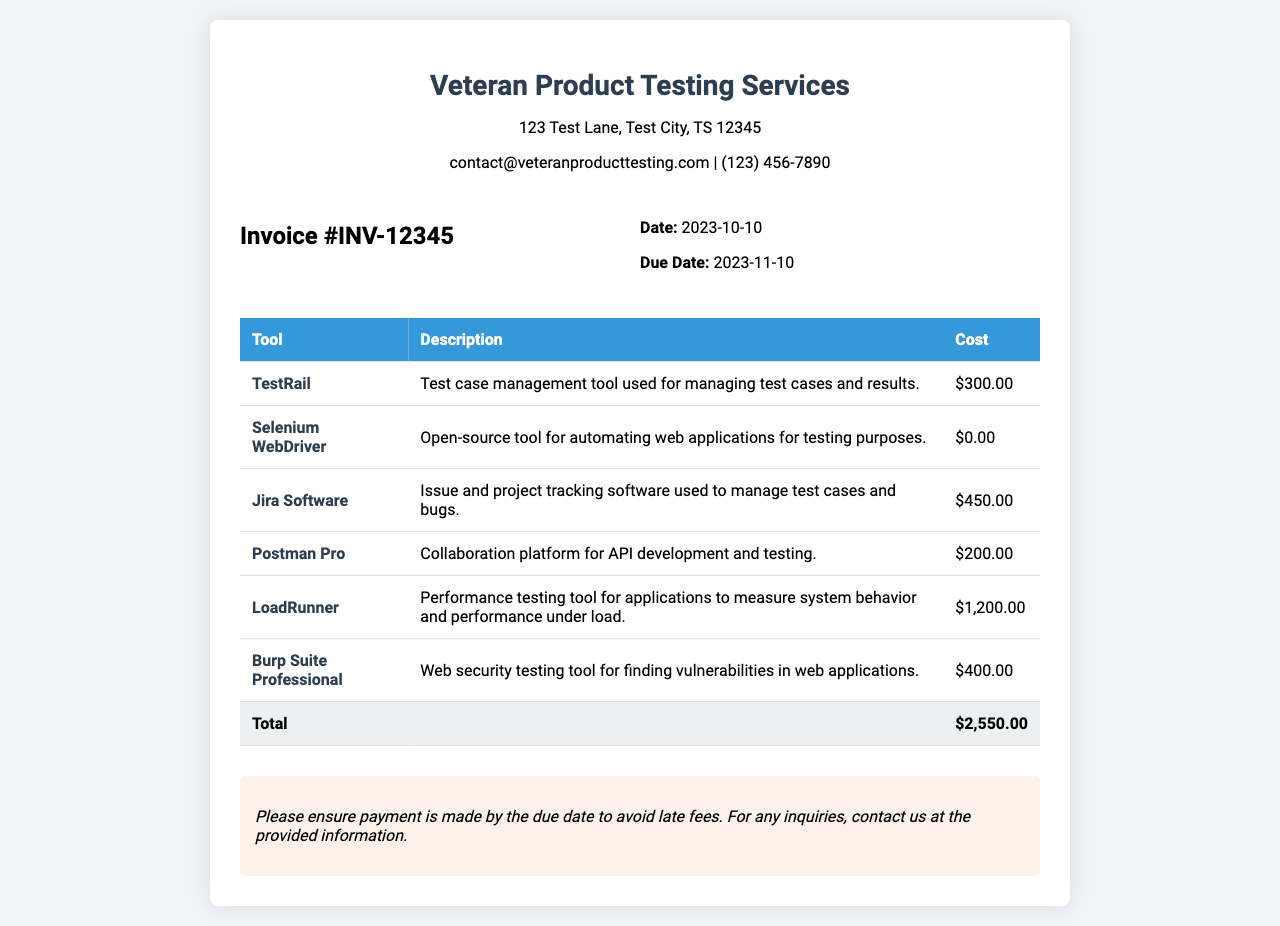What is the invoice number? The invoice number is explicitly listed in the document as "Invoice #INV-12345."
Answer: INV-12345 What is the total cost of the tools? The total cost is summarized at the bottom of the invoice as "$2,550.00."
Answer: $2,550.00 What tool has the highest cost? The highest cost tool is indicated in the cost column, which is "LoadRunner" at "$1,200.00."
Answer: LoadRunner What is the due date for the payment? The due date is specified under the invoice details as "2023-11-10."
Answer: 2023-11-10 How many tools are listed in the invoice? The number of tools is determined by counting the rows, which totals six tools listed in the table.
Answer: 6 What company issued the invoice? The company name is presented at the top of the document as "Veteran Product Testing Services."
Answer: Veteran Product Testing Services Which tool is used for issue and project tracking? The description indicates that "Jira Software" is the tool used for issue and project tracking.
Answer: Jira Software What is the cost of the TestRail tool? The specific cost of TestRail is displayed in the table as "$300.00."
Answer: $300.00 What is the purpose of the LoadRunner tool? The purpose of LoadRunner is described as performance testing for applications, measuring behavior and performance under load.
Answer: Performance testing 